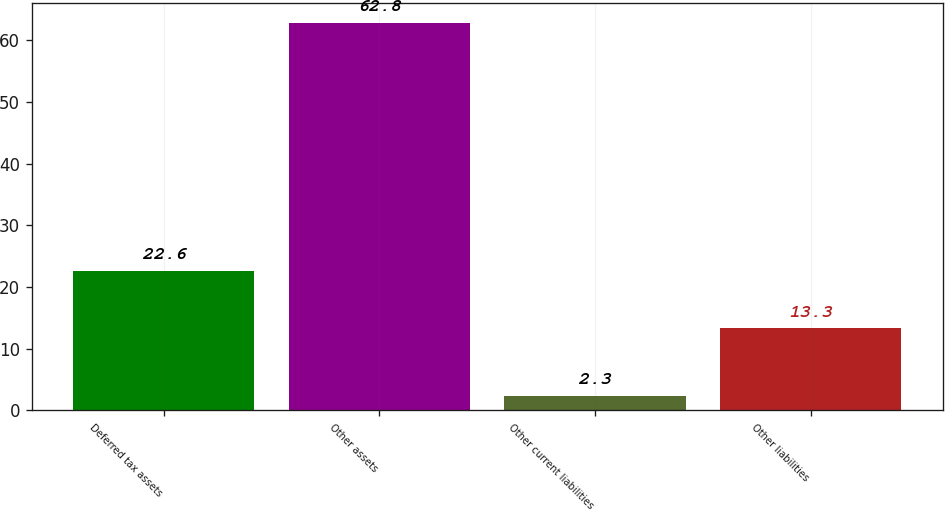<chart> <loc_0><loc_0><loc_500><loc_500><bar_chart><fcel>Deferred tax assets<fcel>Other assets<fcel>Other current liabilities<fcel>Other liabilities<nl><fcel>22.6<fcel>62.8<fcel>2.3<fcel>13.3<nl></chart> 